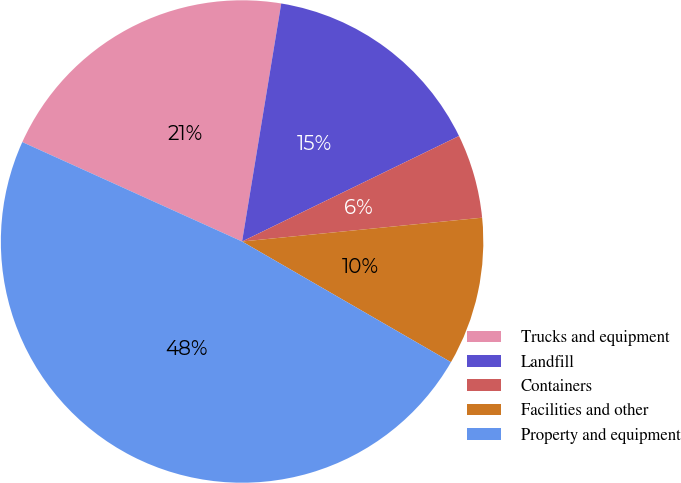Convert chart. <chart><loc_0><loc_0><loc_500><loc_500><pie_chart><fcel>Trucks and equipment<fcel>Landfill<fcel>Containers<fcel>Facilities and other<fcel>Property and equipment<nl><fcel>20.83%<fcel>15.2%<fcel>5.63%<fcel>9.91%<fcel>48.42%<nl></chart> 